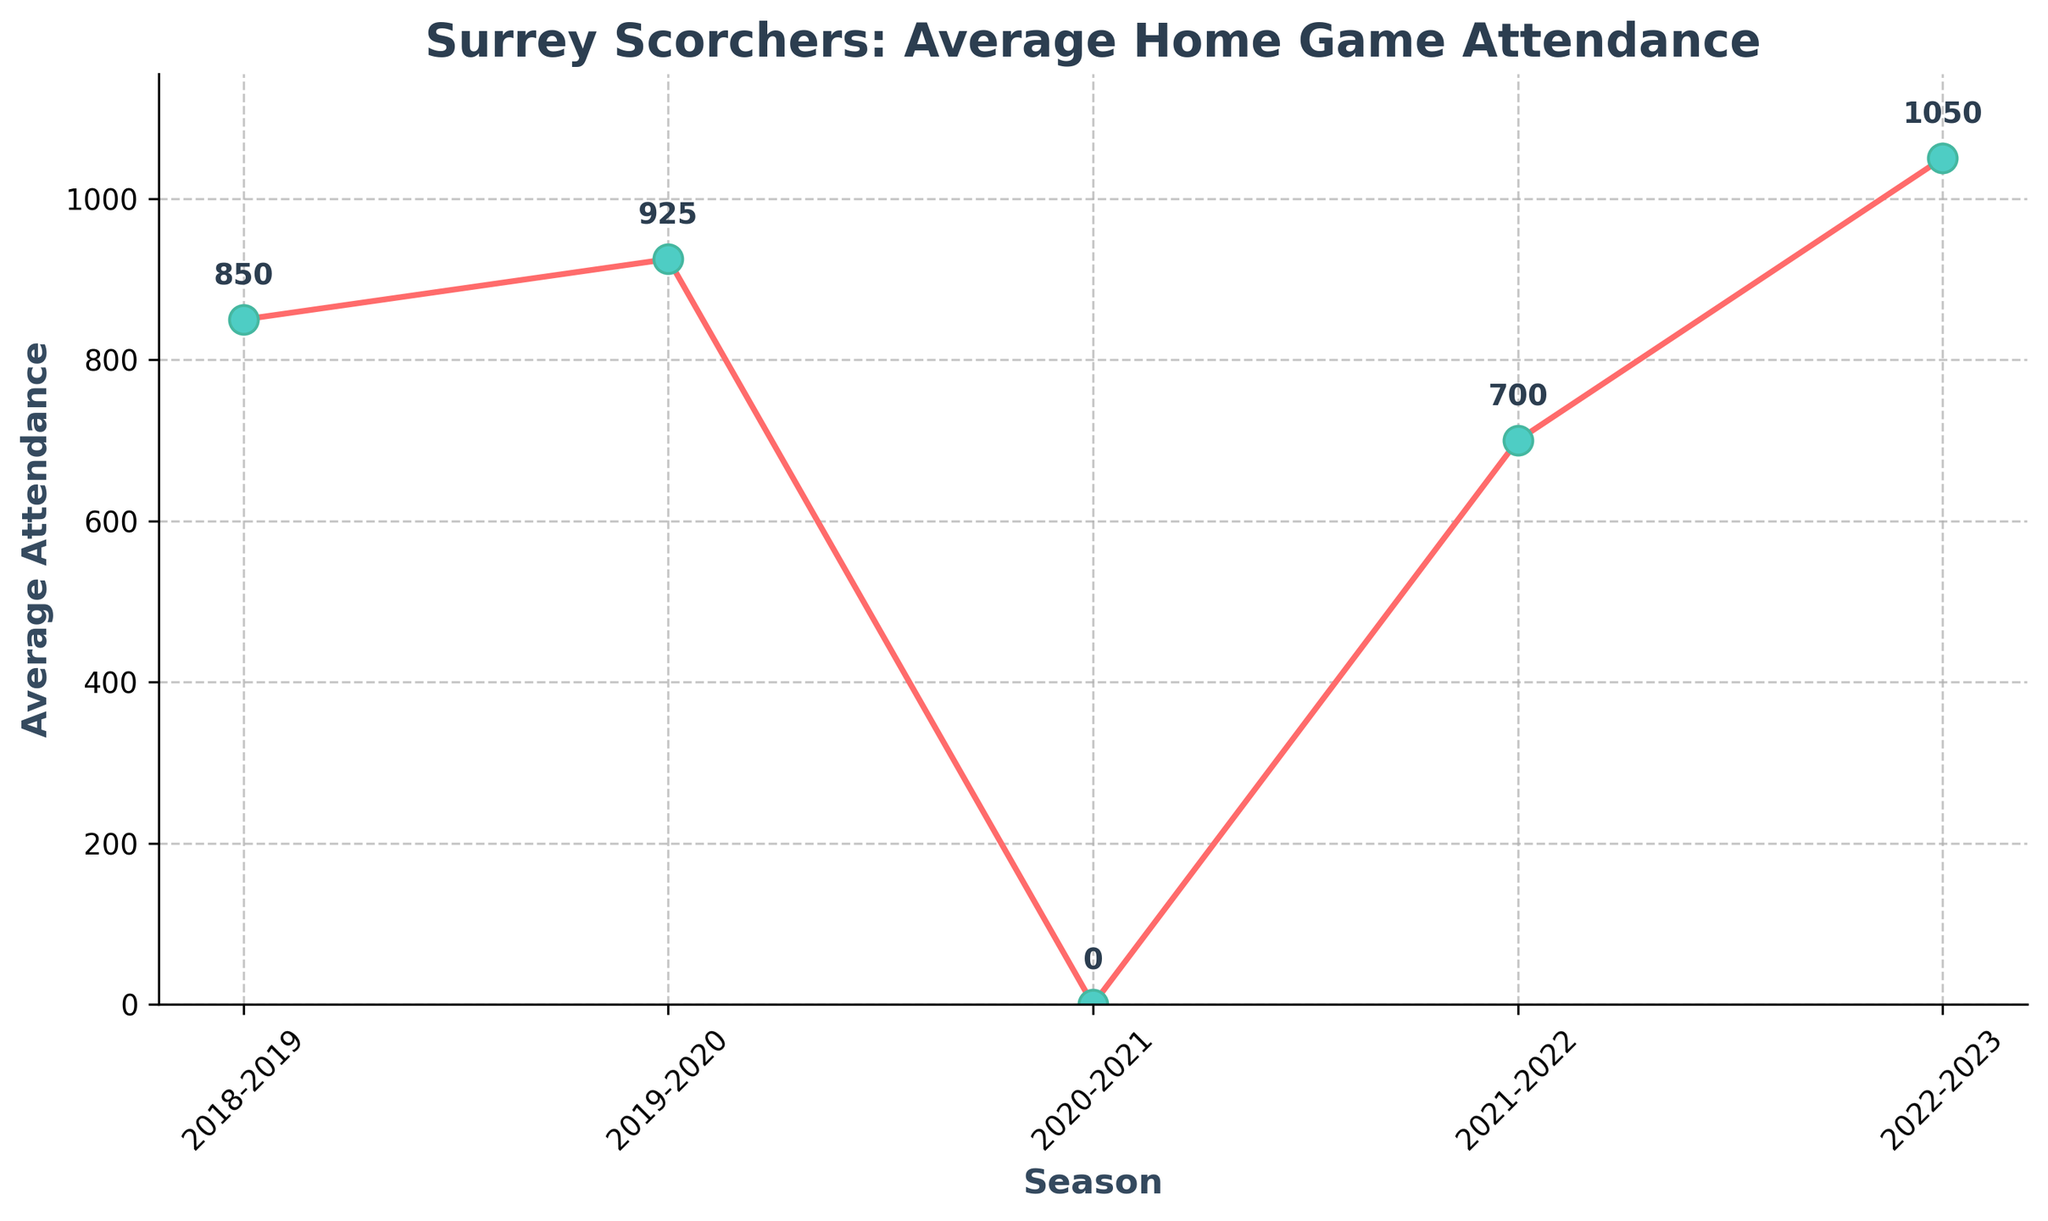What was the average attendance in the 2018-2019 season? According to the plot, the average attendance for the 2018-2019 season is labeled and marked at one of the points on the line.
Answer: 850 What is the trend in average attendance from the 2019-2020 season to the 2020-2021 season? Observing the plot, the line shows a decrease in attendance from 925 in the 2019-2020 season to 0 in the 2020-2021 season.
Answer: Decrease Which season had the highest average attendance? By looking at the highest point on the graph, we can see that the 2022-2023 season had the highest average attendance at 1050.
Answer: 2022-2023 How did the average attendance change from the 2021-2022 season to the 2022-2023 season? The plot shows a significant increase in average attendance from 700 in the 2021-2022 season to 1050 in the 2022-2023 season.
Answer: Increase Calculate the percentage change in attendance from the 2018-2019 season to the 2022-2023 season. The percentage change can be calculated with the formula: ((new value - old value) / old value) * 100. So, ((1050 - 850) / 850) * 100 = 23.53%.
Answer: 23.53% Was there any season where the average attendance was zero? If yes, which one? The plot shows that the data point for the 2020-2021 season is at zero.
Answer: 2020-2021 Compare the average attendance of the 2019-2020 season to the 2021-2022 season. Which one had a higher attendance and by how much? From the graph, we see that the 2019-2020 season had 925, and the 2021-2022 season had 700. The difference is 925 - 700 = 225.
Answer: 2019-2020 by 225 What visual element indicates the value of average attendance for each season on the graph? The data points on the line chart are marked with colored circles, and the exact values are annotated next to each point.
Answer: Colored circles and annotations If you excluded the data from the 2020-2021 season, what would be the new average attendance over the remaining seasons? The values to consider are: 850, 925, 700, and 1050. The sum is 3525 and there are 4 seasons, so the average is 3525 / 4 = 881.25.
Answer: 881.25 